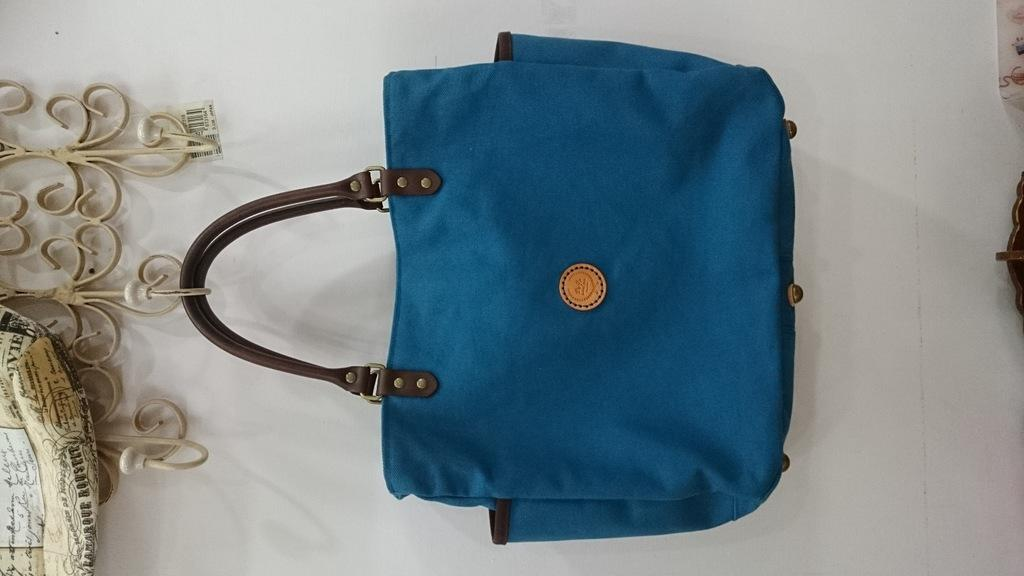What object is present in the image that is commonly used for carrying items? There is a bag in the image. What object is present in the image that is commonly used for hanging clothes? There is a hanger in the image. What type of string is attached to the girl's dress in the image? There is no girl present in the image, and therefore no string attached to a dress. 